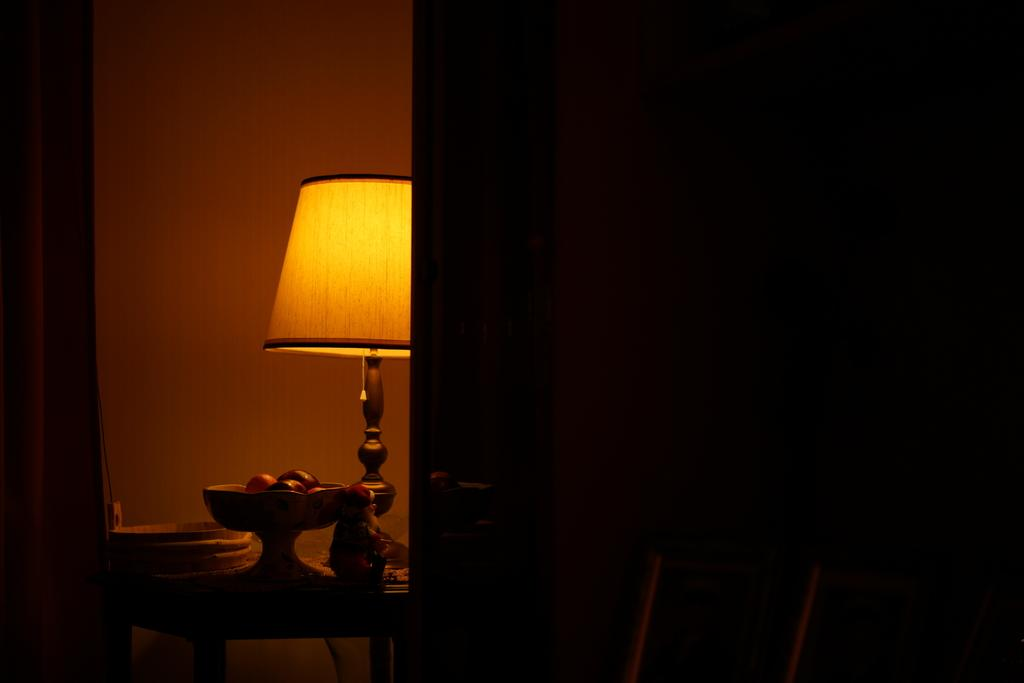What is on the table in the image? There is a lamp and a toy on the table. Can you describe any other objects on the table? There are other unspecified objects on the table. What type of steam is visible coming from the lamp in the image? There is no steam visible coming from the lamp in the image. 